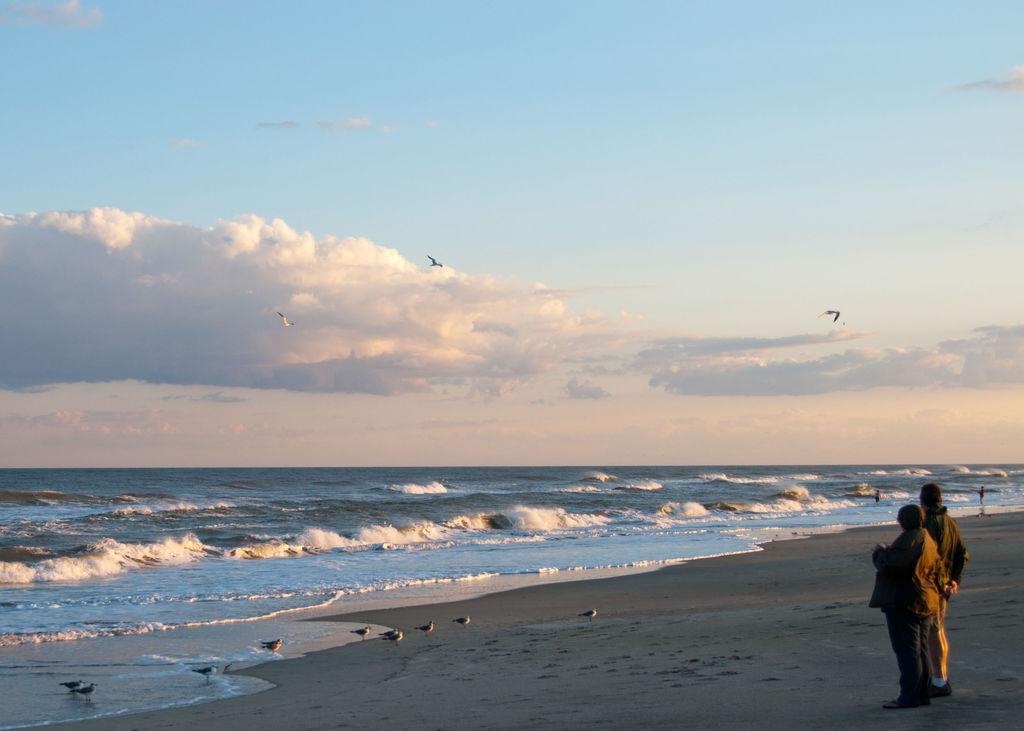Can you describe this image briefly? In the image we can see there are people standing on the sand and there are birds standing on the ground near the sea shore. Behind there is sea and there are birds flying in the sky. There is a cloudy sky. 